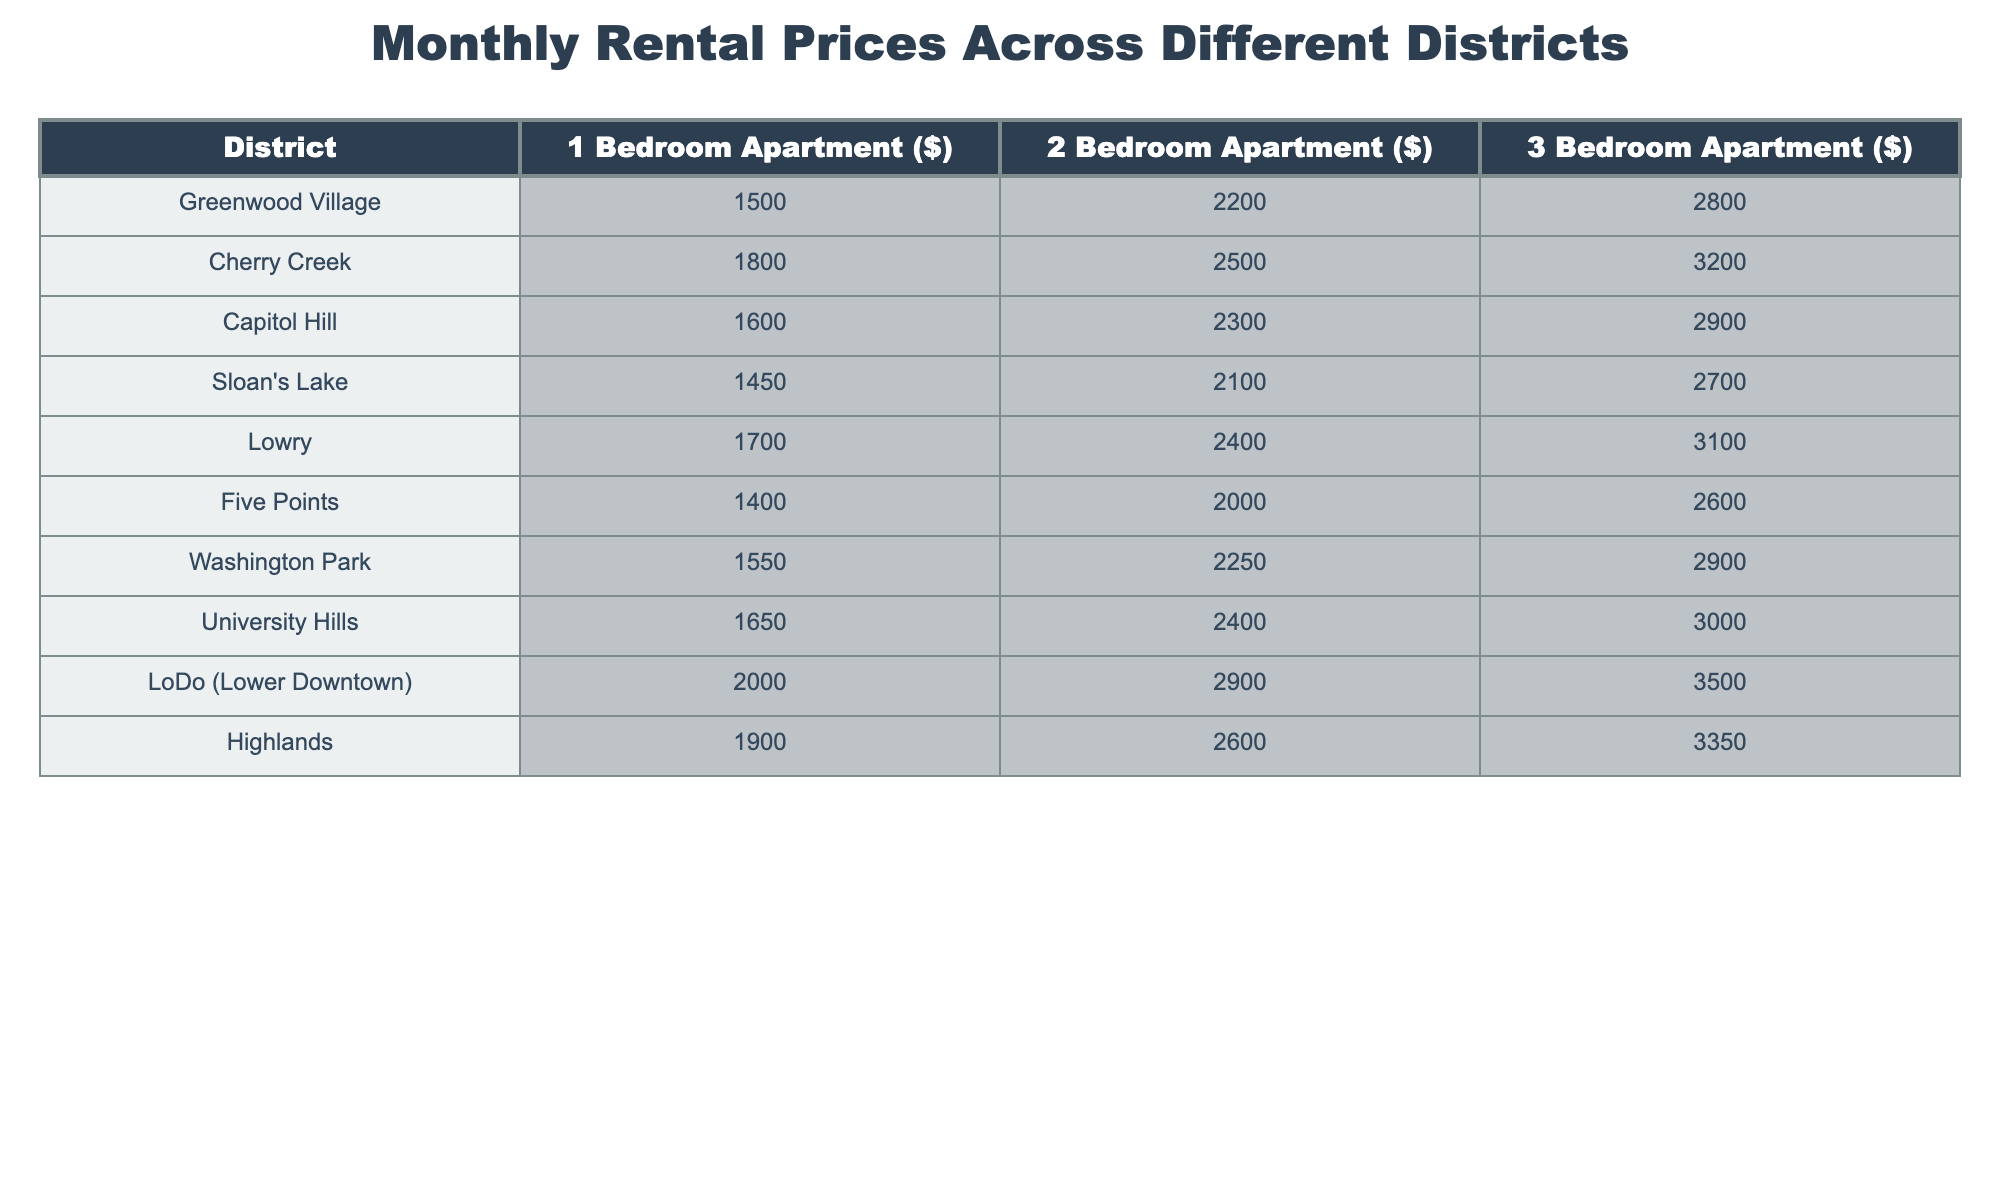What is the rental price of a 1-bedroom apartment in Cherry Creek? The table shows the rental prices for various districts, and Cherry Creek has a 1-bedroom apartment priced at $1800.
Answer: $1800 Which district has the highest rental price for a 3-bedroom apartment? Looking at the 3-bedroom apartment column, LoDo (Lower Downtown) has the highest price of $3500.
Answer: LoDo (Lower Downtown) What is the difference in price between a 1-bedroom apartment in Greenwood Village and Five Points? The 1-bedroom price in Greenwood Village is $1500 and in Five Points is $1400. The difference is $1500 - $1400 = $100.
Answer: $100 What is the average rental price for a 2-bedroom apartment across all districts? First, we sum the 2-bedroom prices: $2200 + $2500 + $2300 + $2100 + $2400 + $2000 + $2250 + $2400 + $2900 + $2600 = $24,250. There are 10 districts, so the average is $24,250 / 10 = $2,425.
Answer: $2,425 Is the rental price for a 3-bedroom apartment in Capitol Hill lower than that in Washington Park? Capitol Hill has a price of $2900 and Washington Park has a price of $2900 as well. They are equal, which means Capitol Hill's price is not lower.
Answer: No Which district has the lowest overall rental prices when considering all apartment types? To find the lowest overall rental prices, we compare the average price of each district's apartments. Summing each district's rental prices and averaging them gives us: Greenwood Village ($1500 + $2200 + $2800 = $6500; average = $2166.67), Cherry Creek ($1800 + $2500 + $3200 = $7500; average = $2500), Capitol Hill ($1600 + $2300 + $2900 = $6800; average = $2266.67), Sloan's Lake ($1450 + $2100 + $2700 = $6250; average = $2083.33), and so on. After evaluating all districts, Five Points has the lowest average at $2000.
Answer: Five Points How much more does a 3-bedroom apartment cost in LoDo compared to a 1-bedroom apartment in Greenwood Village? The 3-bedroom apartment in LoDo costs $3500, while the 1-bedroom in Greenwood Village costs $1500. The difference is $3500 - $1500 = $2000.
Answer: $2000 What is the rental price for a 2-bedroom apartment in Lowry? According to the table, the 2-bedroom apartment in Lowry is listed at $2400.
Answer: $2400 If someone wanted to spend no more than $2000 on a 2-bedroom apartment, which districts would they consider? We look for districts with a 2-bedroom price of $2000 or less. The only applicable district is Five Points at $2000, while others like Sloan's Lake ($2100) and all others exceed this limit.
Answer: Five Points Are the prices for a 1-bedroom apartment in University Hills and Washington Park equal? The 1-bedroom apartment in University Hills is $1650, while in Washington Park it is $1550. Since $1650 is greater than $1550, they are not equal.
Answer: No 